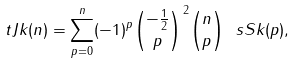<formula> <loc_0><loc_0><loc_500><loc_500>\ t J k ( n ) = \sum _ { p = 0 } ^ { n } ( - 1 ) ^ { p } \binom { - \frac { 1 } { 2 } } p ^ { \, 2 } \binom { n } { p } \ s S k ( p ) ,</formula> 